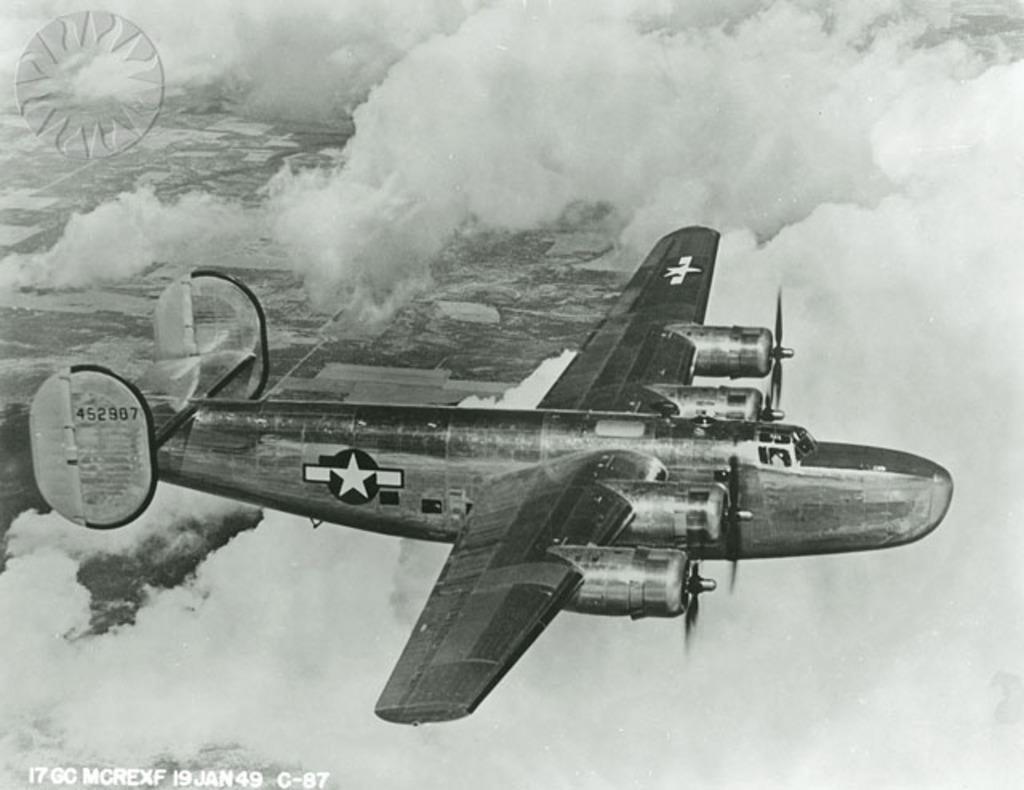<image>
Relay a brief, clear account of the picture shown. A flying bomber is above the clouds with a tail number 452907. 